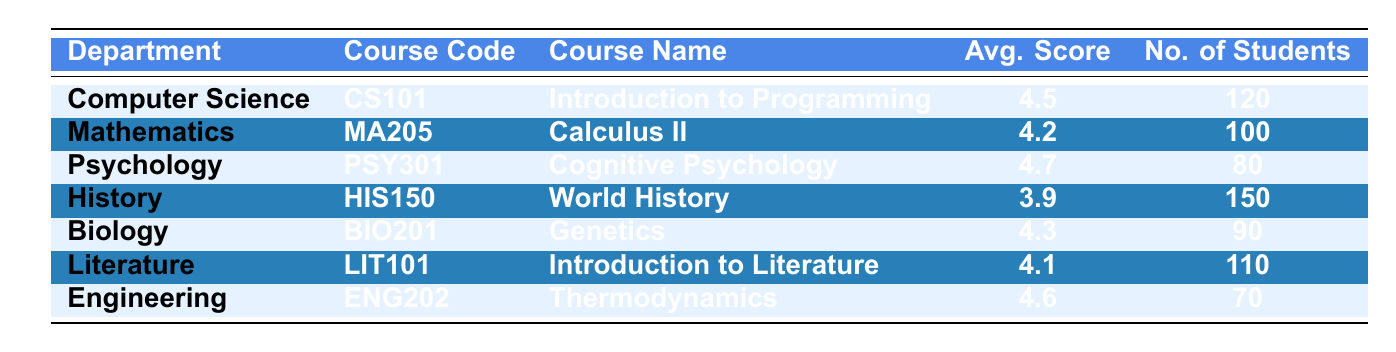What is the average score for the Psychology course? The Psychology course is listed as "Cognitive Psychology" with an average score of 4.7. This information can be found directly in the table under the relevant department and course.
Answer: 4.7 Which department has the least number of students enrolled? By examining the "No. of Students" column, I see that Engineering has the least number of students at 70. This is lower than all other departments noted in the table.
Answer: Engineering What is the total number of students enrolled in all courses combined? To find the total number of students, I add all the values in the "No. of Students" column: 120 (Computer Science) + 100 (Mathematics) + 80 (Psychology) + 150 (History) + 90 (Biology) + 110 (Literature) + 70 (Engineering) = 720.
Answer: 720 Is the average score for the Literature course greater than 4.0? The average score for Literature is 4.1, which is indeed greater than 4.0. This can be confirmed by looking at the average score listed for that course in the table.
Answer: Yes What is the average score calculation for the courses that have more than 100 students? The courses with more than 100 students are "Introduction to Programming" (4.5), "World History" (3.9), and "Introduction to Literature" (4.1). To find the average: (4.5 + 3.9 + 4.1) / 3 = 4.1667, rounding to two decimal places gives 4.17. Therefore, the overall average score of these courses is approximately 4.17.
Answer: 4.17 Does Biology have a higher average score than History? Biology averages 4.3, while History averages only 3.9. Comparing these values shows that Biology scores higher than History.
Answer: Yes What is the average score for the courses in the Engineering and Mathematics departments? For Engineering (4.6) and Mathematics (4.2), the average score is calculated as (4.6 + 4.2) / 2 = 4.4. This involves summing the two scores and dividing by the number of departments considered.
Answer: 4.4 Which course has the highest average score and what is that score? The course with the highest average score is "Cognitive Psychology" from the Psychology department, which has an average score of 4.7. This is found by comparing all average scores listed in the table and identifying the maximum value.
Answer: 4.7 How many departments scored above an average score of 4.4? The departments with scores above 4.4 are Computer Science (4.5), Psychology (4.7), and Engineering (4.6). This gives a total of three departments that exceed the average of 4.4.
Answer: 3 